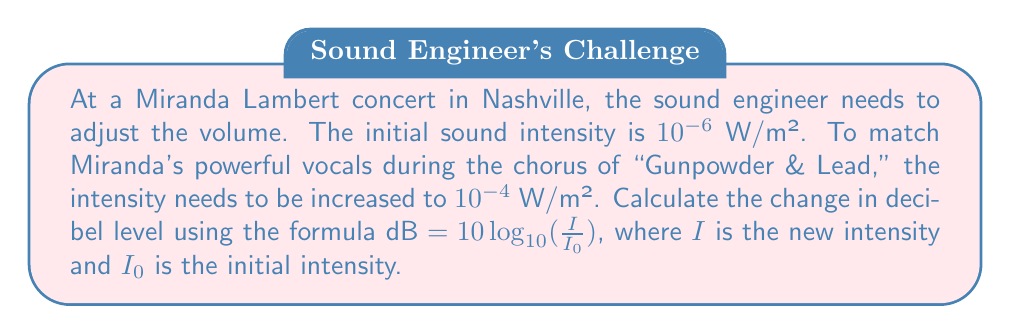What is the answer to this math problem? To solve this problem, we'll use the given formula and the information provided:

$\text{dB} = 10 \log_{10}(\frac{I}{I_0})$

Where:
$I = 10^{-4}$ W/m² (new intensity)
$I_0 = 10^{-6}$ W/m² (initial intensity)

Let's substitute these values into the formula:

$$\begin{align}
\text{dB} &= 10 \log_{10}(\frac{10^{-4}}{10^{-6}}) \\[10pt]
&= 10 \log_{10}(10^2) \\[10pt]
&= 10 \cdot 2 \\[10pt]
&= 20
\end{align}$$

The change in decibel level is positive, indicating an increase in volume.
Answer: The change in decibel level is 20 dB. 